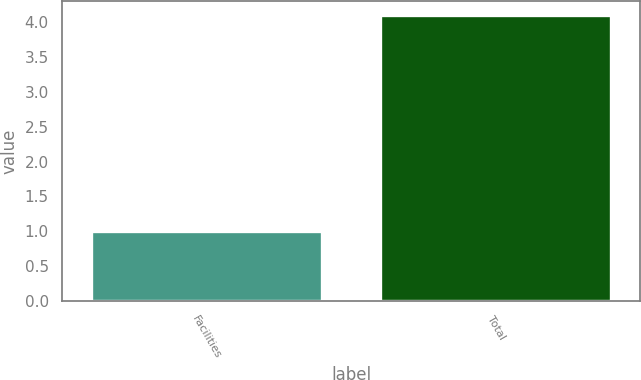Convert chart. <chart><loc_0><loc_0><loc_500><loc_500><bar_chart><fcel>Facilities<fcel>Total<nl><fcel>1<fcel>4.1<nl></chart> 